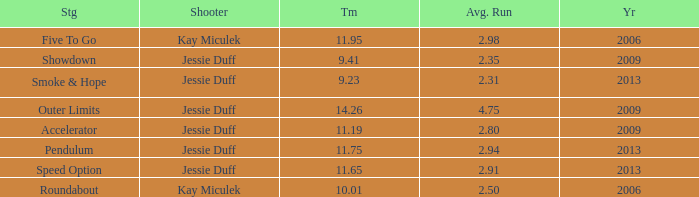What is the total years with average runs less than 4.75 and a time of 14.26? 0.0. 